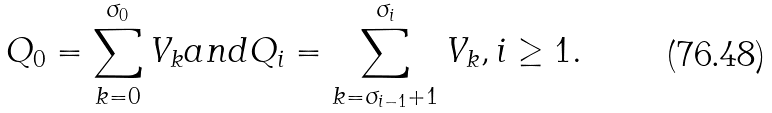<formula> <loc_0><loc_0><loc_500><loc_500>Q _ { 0 } = \sum _ { k = 0 } ^ { \sigma _ { 0 } } V _ { k } a n d Q _ { i } = \sum _ { k = \sigma _ { i - 1 } + 1 } ^ { \sigma _ { i } } V _ { k } , i \geq 1 .</formula> 